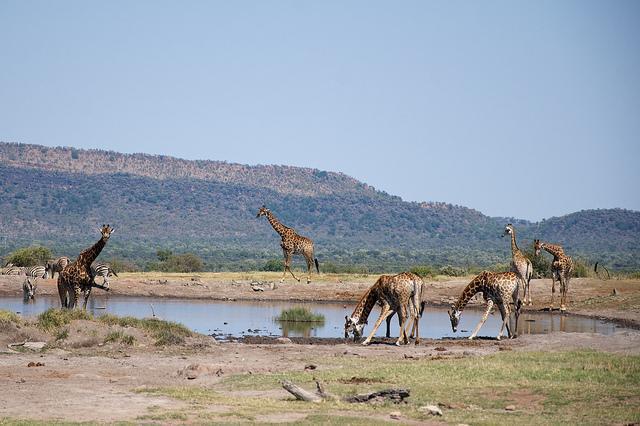How many of the giraffes are taking a drink in the water?
Make your selection and explain in format: 'Answer: answer
Rationale: rationale.'
Options: Six, one, four, three. Answer: six.
Rationale: All you have to do is count the animals near the water. 